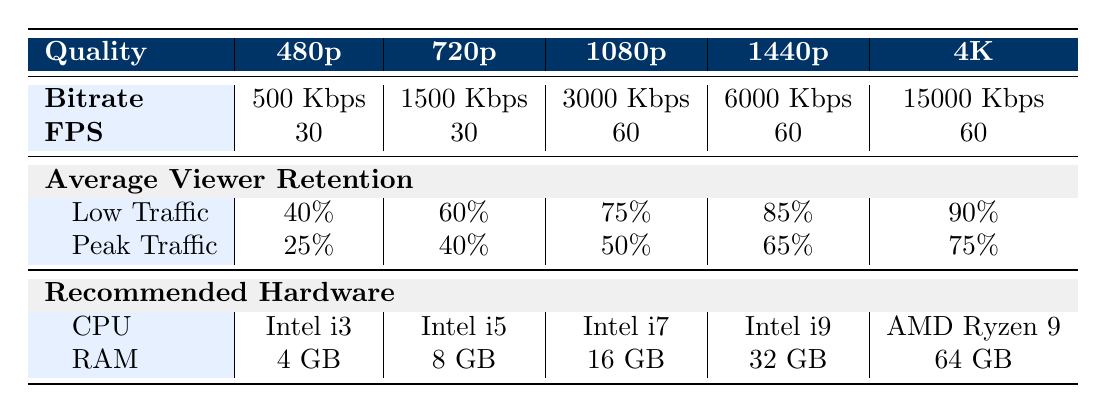What is the average viewer retention at low traffic for 720p? The average viewer retention at low traffic for 720p can be found in the corresponding cell in the table. It states 60%.
Answer: 60% What is the fps (frames per second) for 1080p quality? The table specifies the frames per second for 1080p in the FPS row, which is 60.
Answer: 60 Which quality setting has the highest average viewer retention at peak traffic? We need to compare peak traffic retention across all quality settings. The values are: 25% for 480p, 40% for 720p, 50% for 1080p, 65% for 1440p, and 75% for 4K. The highest value is 75% for 4K.
Answer: 4K What is the difference in average viewer retention at low traffic between 1440p and 480p? To find the difference at low traffic, we check the values: 85% for 1440p and 40% for 480p. The difference is calculated as 85% - 40% = 45%.
Answer: 45% Is the recommended CPU for 4K streaming an AMD Ryzen 9? We can check the recommended CPU for 4K in the table, which confirms that it is indeed an AMD Ryzen 9.
Answer: Yes Which quality setting requires the most RAM? Looking at the RAM requirements listed for each quality setting, 64 GB for 4K is the highest among all the settings.
Answer: 4K What would be the average viewer retention at low traffic for all quality settings combined? The average can be calculated by adding the low traffic retention percentages: 40% + 60% + 75% + 85% + 90%, totaling 350%. Then divide by the number of settings, which is 5. The average is 350% / 5 = 70%.
Answer: 70% Does 1080p have a lower bitrate than 720p? The table shows the bitrates: 3000 Kbps for 1080p and 1500 Kbps for 720p. Since 3000 is greater than 1500, this statement is false.
Answer: No 